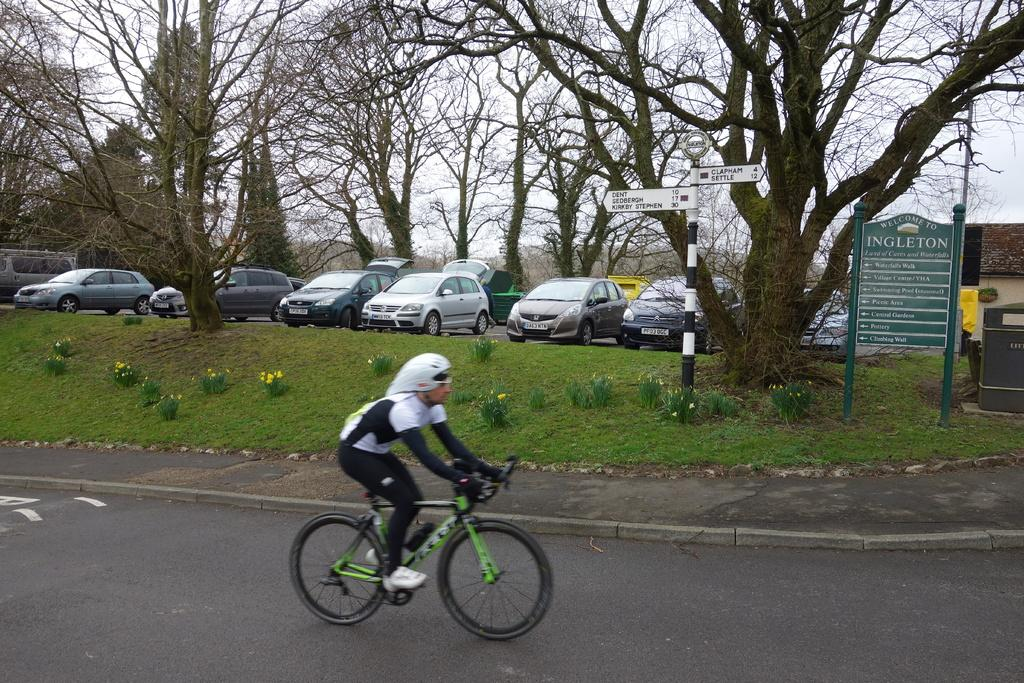What is the main subject of the image? There is a person riding a bicycle in the image. What can be seen in the background of the image? There are cars, trees, signboards, a green board, and a house visible in the background. What is the color of the sky in the image? The sky is blue and white in color. How many cakes are being served to the visitor in the image? There is no visitor or cakes present in the image. What type of sponge is being used by the person riding the bicycle in the image? There is no sponge visible in the image; the person is riding a bicycle. 